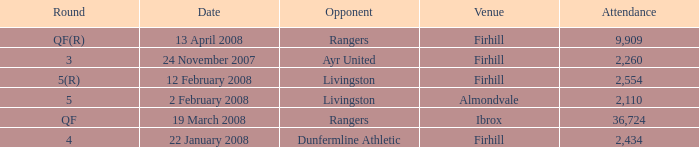Who was the opponent at the qf(r) round? Rangers. 